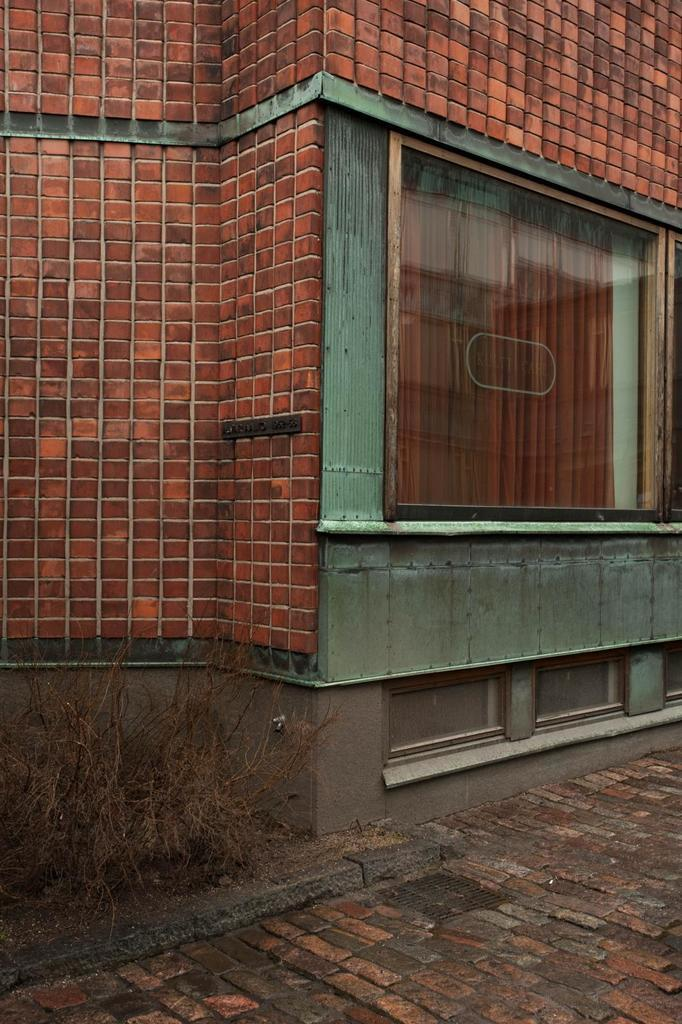What type of structure is visible in the image? There is a building in the image. What is the color of the building? The building is brick in color. Are there any specific features of the building that can be identified? Yes, there is a glass window in the right corner of the building. What grade does the nut receive for its performance in the image? There is no nut present in the image, and therefore no performance to evaluate. 